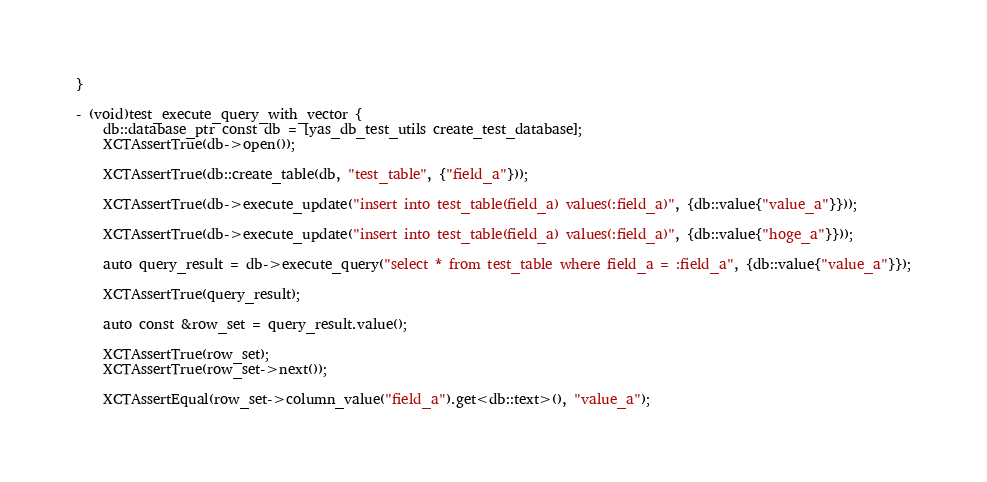<code> <loc_0><loc_0><loc_500><loc_500><_ObjectiveC_>}

- (void)test_execute_query_with_vector {
    db::database_ptr const db = [yas_db_test_utils create_test_database];
    XCTAssertTrue(db->open());

    XCTAssertTrue(db::create_table(db, "test_table", {"field_a"}));

    XCTAssertTrue(db->execute_update("insert into test_table(field_a) values(:field_a)", {db::value{"value_a"}}));

    XCTAssertTrue(db->execute_update("insert into test_table(field_a) values(:field_a)", {db::value{"hoge_a"}}));

    auto query_result = db->execute_query("select * from test_table where field_a = :field_a", {db::value{"value_a"}});

    XCTAssertTrue(query_result);

    auto const &row_set = query_result.value();

    XCTAssertTrue(row_set);
    XCTAssertTrue(row_set->next());

    XCTAssertEqual(row_set->column_value("field_a").get<db::text>(), "value_a");
</code> 